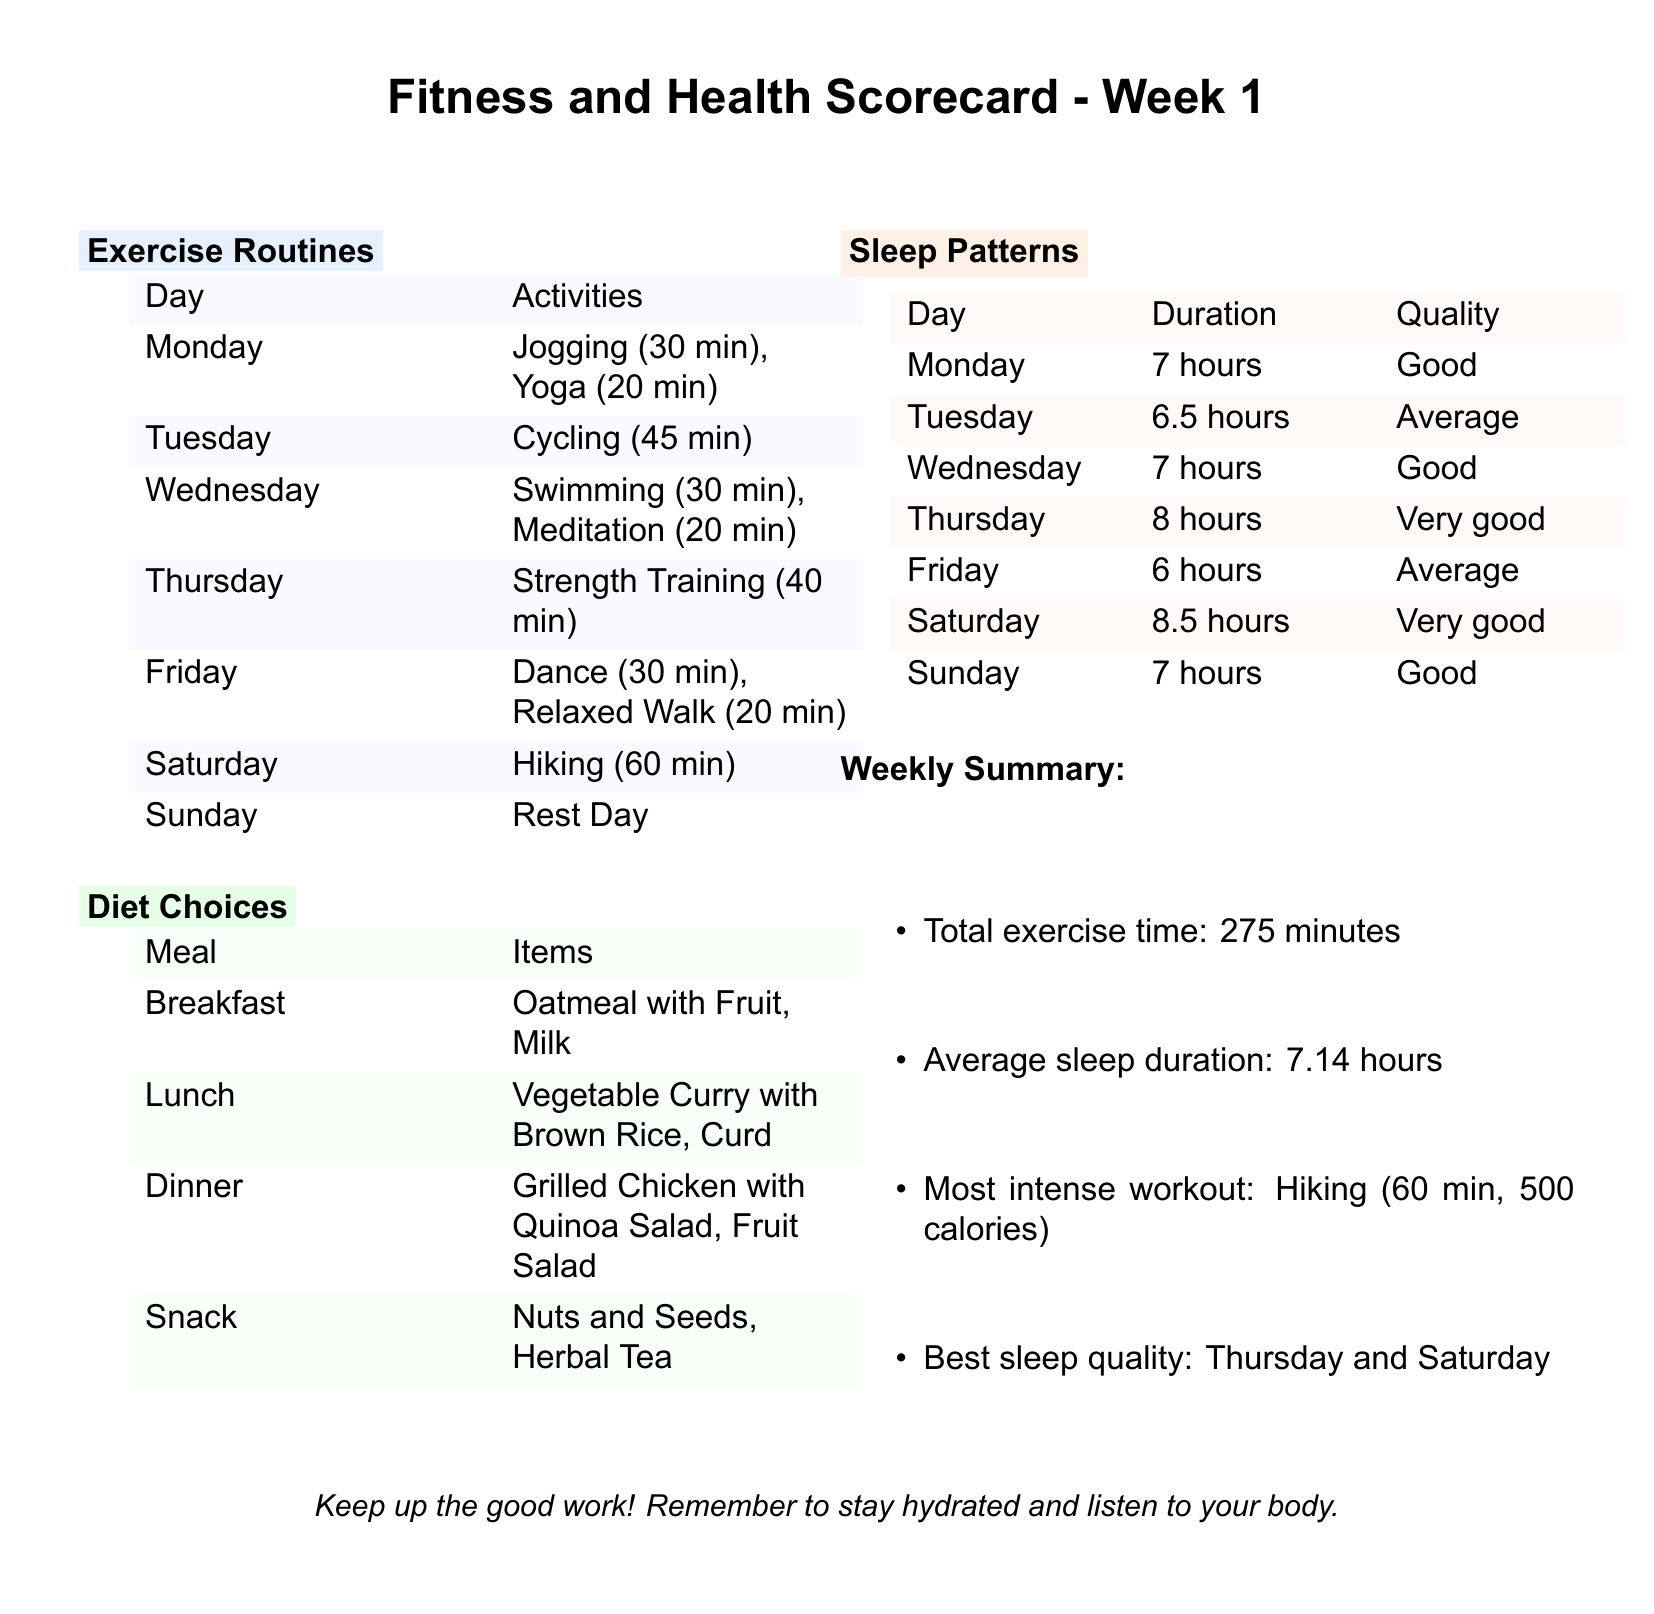What activities were done on Monday? The activities listed for Monday are Jogging and Yoga, specifically for 30 and 20 minutes respectively.
Answer: Jogging (30 min), Yoga (20 min) What is the duration of sleep on Thursday? The duration of sleep recorded for Thursday is 8 hours, as per the sleep patterns section.
Answer: 8 hours Which day had the most intense workout? The most intense workout listed in the summary is Hiking, which lasted 60 minutes and burned 500 calories.
Answer: Hiking (60 min) What items were included in breakfast? Breakfast items listed include Oatmeal with Fruit and Milk.
Answer: Oatmeal with Fruit, Milk What was the average sleep duration for the week? The average sleep duration is calculated as 7.14 hours, which is provided in the weekly summary.
Answer: 7.14 hours What activities were done on Wednesday? The activities listed for Wednesday include Swimming and Meditation for a total of 50 minutes.
Answer: Swimming (30 min), Meditation (20 min) What is the total exercise time for the week? The total exercise time is summarized as 275 minutes in the weekly summary section.
Answer: 275 minutes What is the quality of sleep on Saturday? The quality of sleep recorded for Saturday is classified as Very good, based on the sleep patterns section.
Answer: Very good 